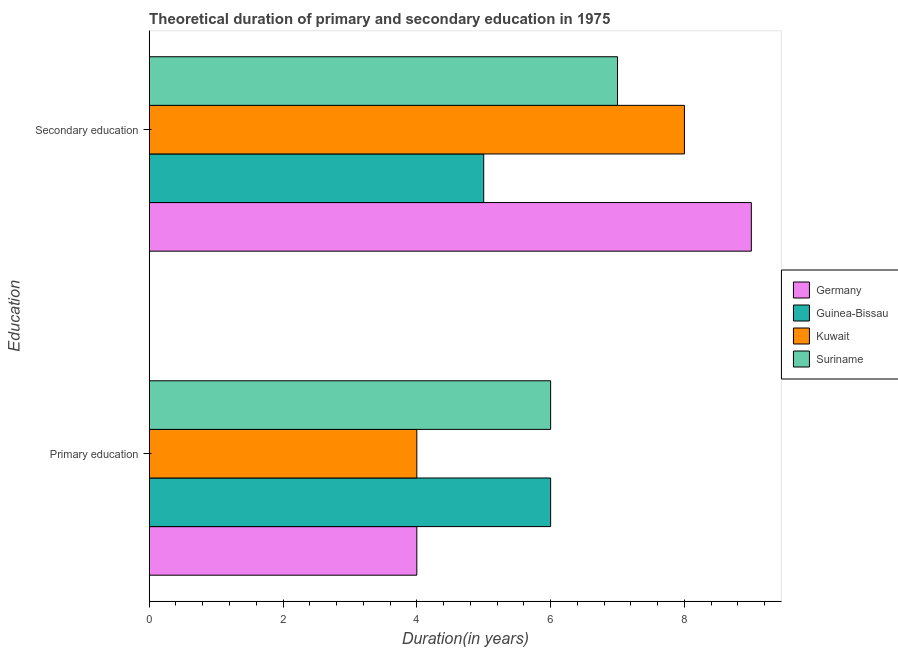How many groups of bars are there?
Keep it short and to the point. 2. What is the duration of secondary education in Guinea-Bissau?
Your answer should be very brief. 5. Across all countries, what is the maximum duration of primary education?
Ensure brevity in your answer.  6. Across all countries, what is the minimum duration of secondary education?
Give a very brief answer. 5. In which country was the duration of primary education maximum?
Ensure brevity in your answer.  Guinea-Bissau. In which country was the duration of secondary education minimum?
Make the answer very short. Guinea-Bissau. What is the total duration of secondary education in the graph?
Provide a succinct answer. 29. What is the difference between the duration of secondary education in Kuwait and that in Guinea-Bissau?
Ensure brevity in your answer.  3. What is the difference between the duration of primary education in Kuwait and the duration of secondary education in Germany?
Your response must be concise. -5. What is the average duration of secondary education per country?
Offer a very short reply. 7.25. What is the difference between the duration of primary education and duration of secondary education in Suriname?
Provide a succinct answer. -1. In how many countries, is the duration of primary education greater than 8.4 years?
Provide a short and direct response. 0. What is the ratio of the duration of secondary education in Suriname to that in Germany?
Your response must be concise. 0.78. Is the duration of secondary education in Germany less than that in Kuwait?
Give a very brief answer. No. In how many countries, is the duration of secondary education greater than the average duration of secondary education taken over all countries?
Provide a succinct answer. 2. What does the 1st bar from the top in Secondary education represents?
Provide a succinct answer. Suriname. What does the 2nd bar from the bottom in Primary education represents?
Keep it short and to the point. Guinea-Bissau. What is the difference between two consecutive major ticks on the X-axis?
Your answer should be compact. 2. Are the values on the major ticks of X-axis written in scientific E-notation?
Your answer should be very brief. No. What is the title of the graph?
Provide a short and direct response. Theoretical duration of primary and secondary education in 1975. What is the label or title of the X-axis?
Provide a succinct answer. Duration(in years). What is the label or title of the Y-axis?
Your response must be concise. Education. What is the Duration(in years) of Germany in Primary education?
Your answer should be compact. 4. What is the Duration(in years) in Kuwait in Primary education?
Your answer should be very brief. 4. What is the Duration(in years) of Suriname in Primary education?
Your answer should be very brief. 6. What is the Duration(in years) in Germany in Secondary education?
Offer a terse response. 9. What is the Duration(in years) in Guinea-Bissau in Secondary education?
Ensure brevity in your answer.  5. What is the Duration(in years) in Kuwait in Secondary education?
Ensure brevity in your answer.  8. Across all Education, what is the maximum Duration(in years) in Germany?
Your response must be concise. 9. What is the total Duration(in years) in Germany in the graph?
Offer a terse response. 13. What is the total Duration(in years) in Guinea-Bissau in the graph?
Offer a terse response. 11. What is the total Duration(in years) in Suriname in the graph?
Provide a succinct answer. 13. What is the difference between the Duration(in years) of Germany in Primary education and that in Secondary education?
Ensure brevity in your answer.  -5. What is the difference between the Duration(in years) in Kuwait in Primary education and that in Secondary education?
Offer a terse response. -4. What is the difference between the Duration(in years) in Suriname in Primary education and that in Secondary education?
Provide a short and direct response. -1. What is the difference between the Duration(in years) in Germany in Primary education and the Duration(in years) in Guinea-Bissau in Secondary education?
Keep it short and to the point. -1. What is the difference between the Duration(in years) of Germany in Primary education and the Duration(in years) of Kuwait in Secondary education?
Provide a succinct answer. -4. What is the difference between the Duration(in years) in Guinea-Bissau in Primary education and the Duration(in years) in Suriname in Secondary education?
Provide a succinct answer. -1. What is the difference between the Duration(in years) in Kuwait in Primary education and the Duration(in years) in Suriname in Secondary education?
Ensure brevity in your answer.  -3. What is the average Duration(in years) of Guinea-Bissau per Education?
Keep it short and to the point. 5.5. What is the difference between the Duration(in years) in Germany and Duration(in years) in Kuwait in Primary education?
Provide a succinct answer. 0. What is the difference between the Duration(in years) of Germany and Duration(in years) of Suriname in Primary education?
Offer a terse response. -2. What is the difference between the Duration(in years) in Guinea-Bissau and Duration(in years) in Suriname in Primary education?
Your answer should be compact. 0. What is the difference between the Duration(in years) in Germany and Duration(in years) in Guinea-Bissau in Secondary education?
Make the answer very short. 4. What is the difference between the Duration(in years) of Guinea-Bissau and Duration(in years) of Kuwait in Secondary education?
Provide a succinct answer. -3. What is the difference between the Duration(in years) in Guinea-Bissau and Duration(in years) in Suriname in Secondary education?
Ensure brevity in your answer.  -2. What is the ratio of the Duration(in years) of Germany in Primary education to that in Secondary education?
Provide a succinct answer. 0.44. What is the ratio of the Duration(in years) of Guinea-Bissau in Primary education to that in Secondary education?
Your response must be concise. 1.2. What is the difference between the highest and the second highest Duration(in years) in Guinea-Bissau?
Keep it short and to the point. 1. What is the difference between the highest and the second highest Duration(in years) of Suriname?
Ensure brevity in your answer.  1. 